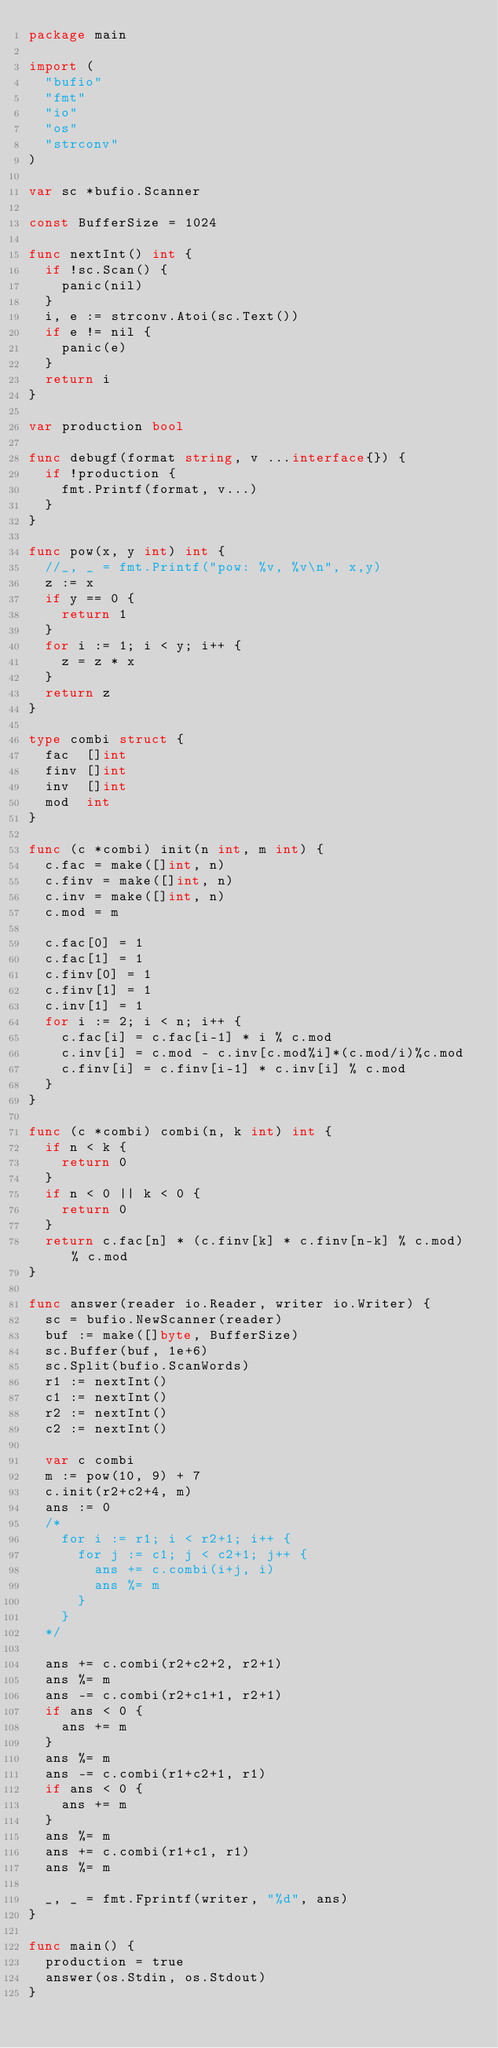<code> <loc_0><loc_0><loc_500><loc_500><_Go_>package main

import (
	"bufio"
	"fmt"
	"io"
	"os"
	"strconv"
)

var sc *bufio.Scanner

const BufferSize = 1024

func nextInt() int {
	if !sc.Scan() {
		panic(nil)
	}
	i, e := strconv.Atoi(sc.Text())
	if e != nil {
		panic(e)
	}
	return i
}

var production bool

func debugf(format string, v ...interface{}) {
	if !production {
		fmt.Printf(format, v...)
	}
}

func pow(x, y int) int {
	//_, _ = fmt.Printf("pow: %v, %v\n", x,y)
	z := x
	if y == 0 {
		return 1
	}
	for i := 1; i < y; i++ {
		z = z * x
	}
	return z
}

type combi struct {
	fac  []int
	finv []int
	inv  []int
	mod  int
}

func (c *combi) init(n int, m int) {
	c.fac = make([]int, n)
	c.finv = make([]int, n)
	c.inv = make([]int, n)
	c.mod = m

	c.fac[0] = 1
	c.fac[1] = 1
	c.finv[0] = 1
	c.finv[1] = 1
	c.inv[1] = 1
	for i := 2; i < n; i++ {
		c.fac[i] = c.fac[i-1] * i % c.mod
		c.inv[i] = c.mod - c.inv[c.mod%i]*(c.mod/i)%c.mod
		c.finv[i] = c.finv[i-1] * c.inv[i] % c.mod
	}
}

func (c *combi) combi(n, k int) int {
	if n < k {
		return 0
	}
	if n < 0 || k < 0 {
		return 0
	}
	return c.fac[n] * (c.finv[k] * c.finv[n-k] % c.mod) % c.mod
}

func answer(reader io.Reader, writer io.Writer) {
	sc = bufio.NewScanner(reader)
	buf := make([]byte, BufferSize)
	sc.Buffer(buf, 1e+6)
	sc.Split(bufio.ScanWords)
	r1 := nextInt()
	c1 := nextInt()
	r2 := nextInt()
	c2 := nextInt()

	var c combi
	m := pow(10, 9) + 7
	c.init(r2+c2+4, m)
	ans := 0
	/*
		for i := r1; i < r2+1; i++ {
			for j := c1; j < c2+1; j++ {
				ans += c.combi(i+j, i)
				ans %= m
			}
		}
	*/

	ans += c.combi(r2+c2+2, r2+1)
	ans %= m
	ans -= c.combi(r2+c1+1, r2+1)
	if ans < 0 {
		ans += m
	}
	ans %= m
	ans -= c.combi(r1+c2+1, r1)
	if ans < 0 {
		ans += m
	}
	ans %= m
	ans += c.combi(r1+c1, r1)
	ans %= m

	_, _ = fmt.Fprintf(writer, "%d", ans)
}

func main() {
	production = true
	answer(os.Stdin, os.Stdout)
}
</code> 